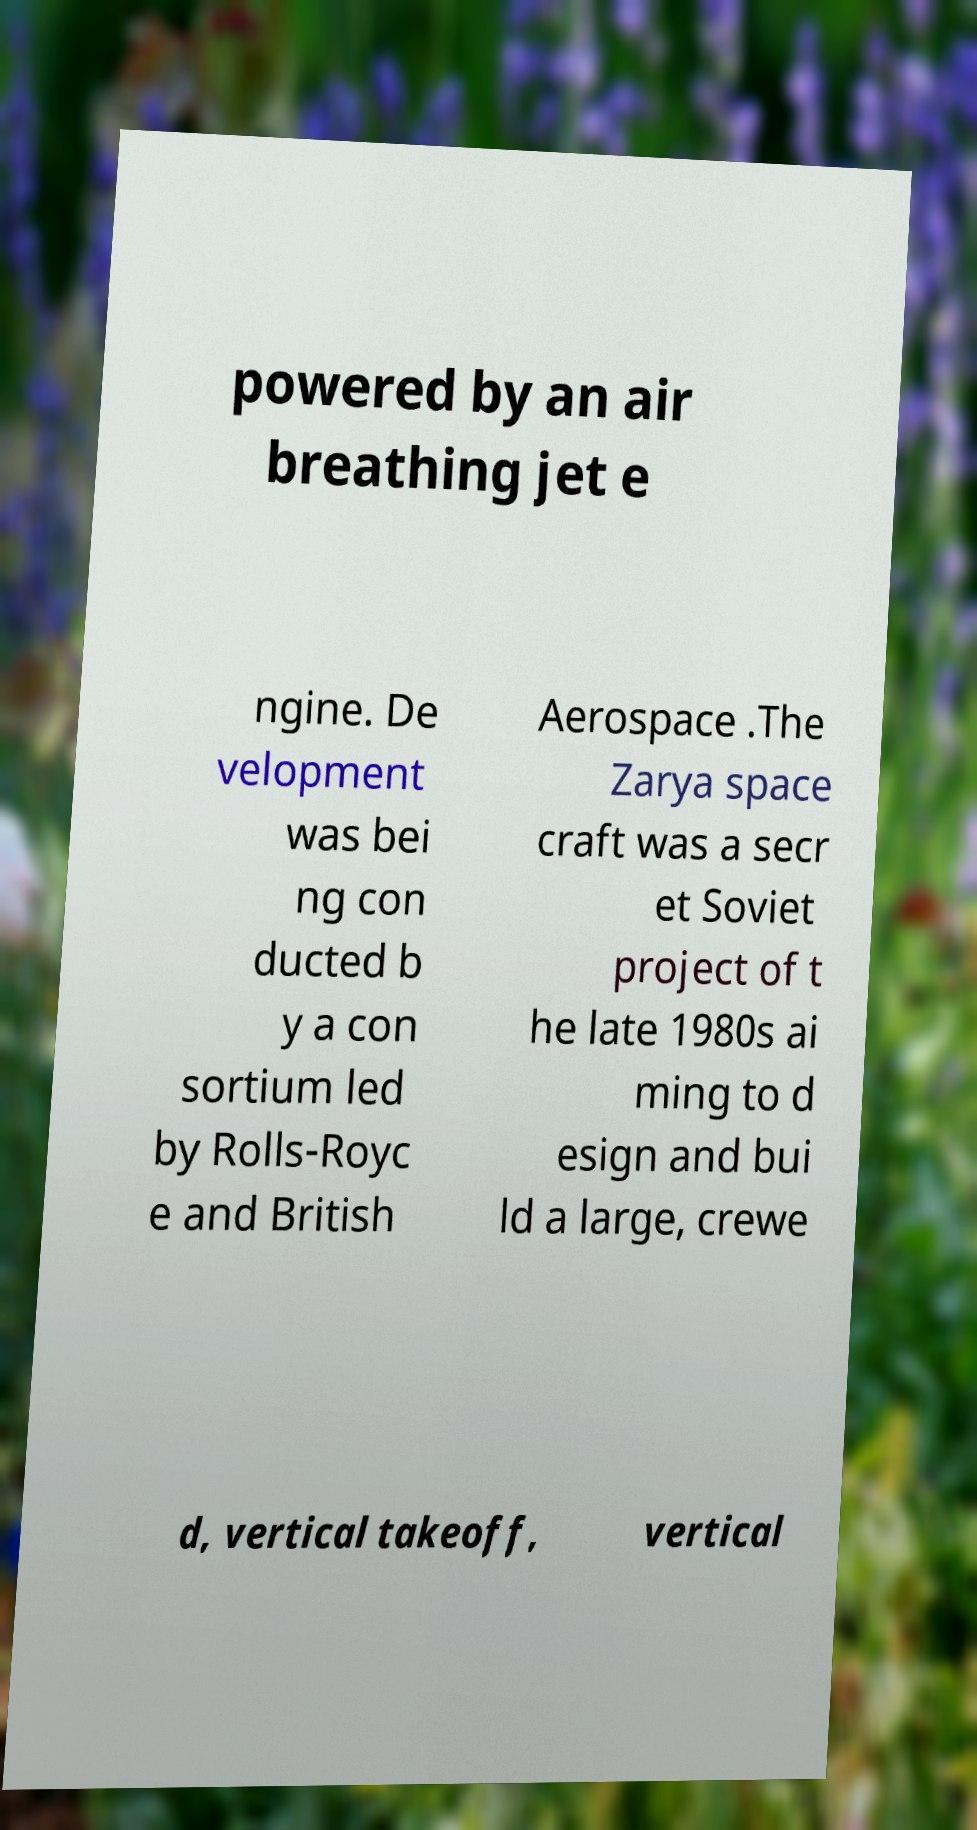Could you assist in decoding the text presented in this image and type it out clearly? powered by an air breathing jet e ngine. De velopment was bei ng con ducted b y a con sortium led by Rolls-Royc e and British Aerospace .The Zarya space craft was a secr et Soviet project of t he late 1980s ai ming to d esign and bui ld a large, crewe d, vertical takeoff, vertical 